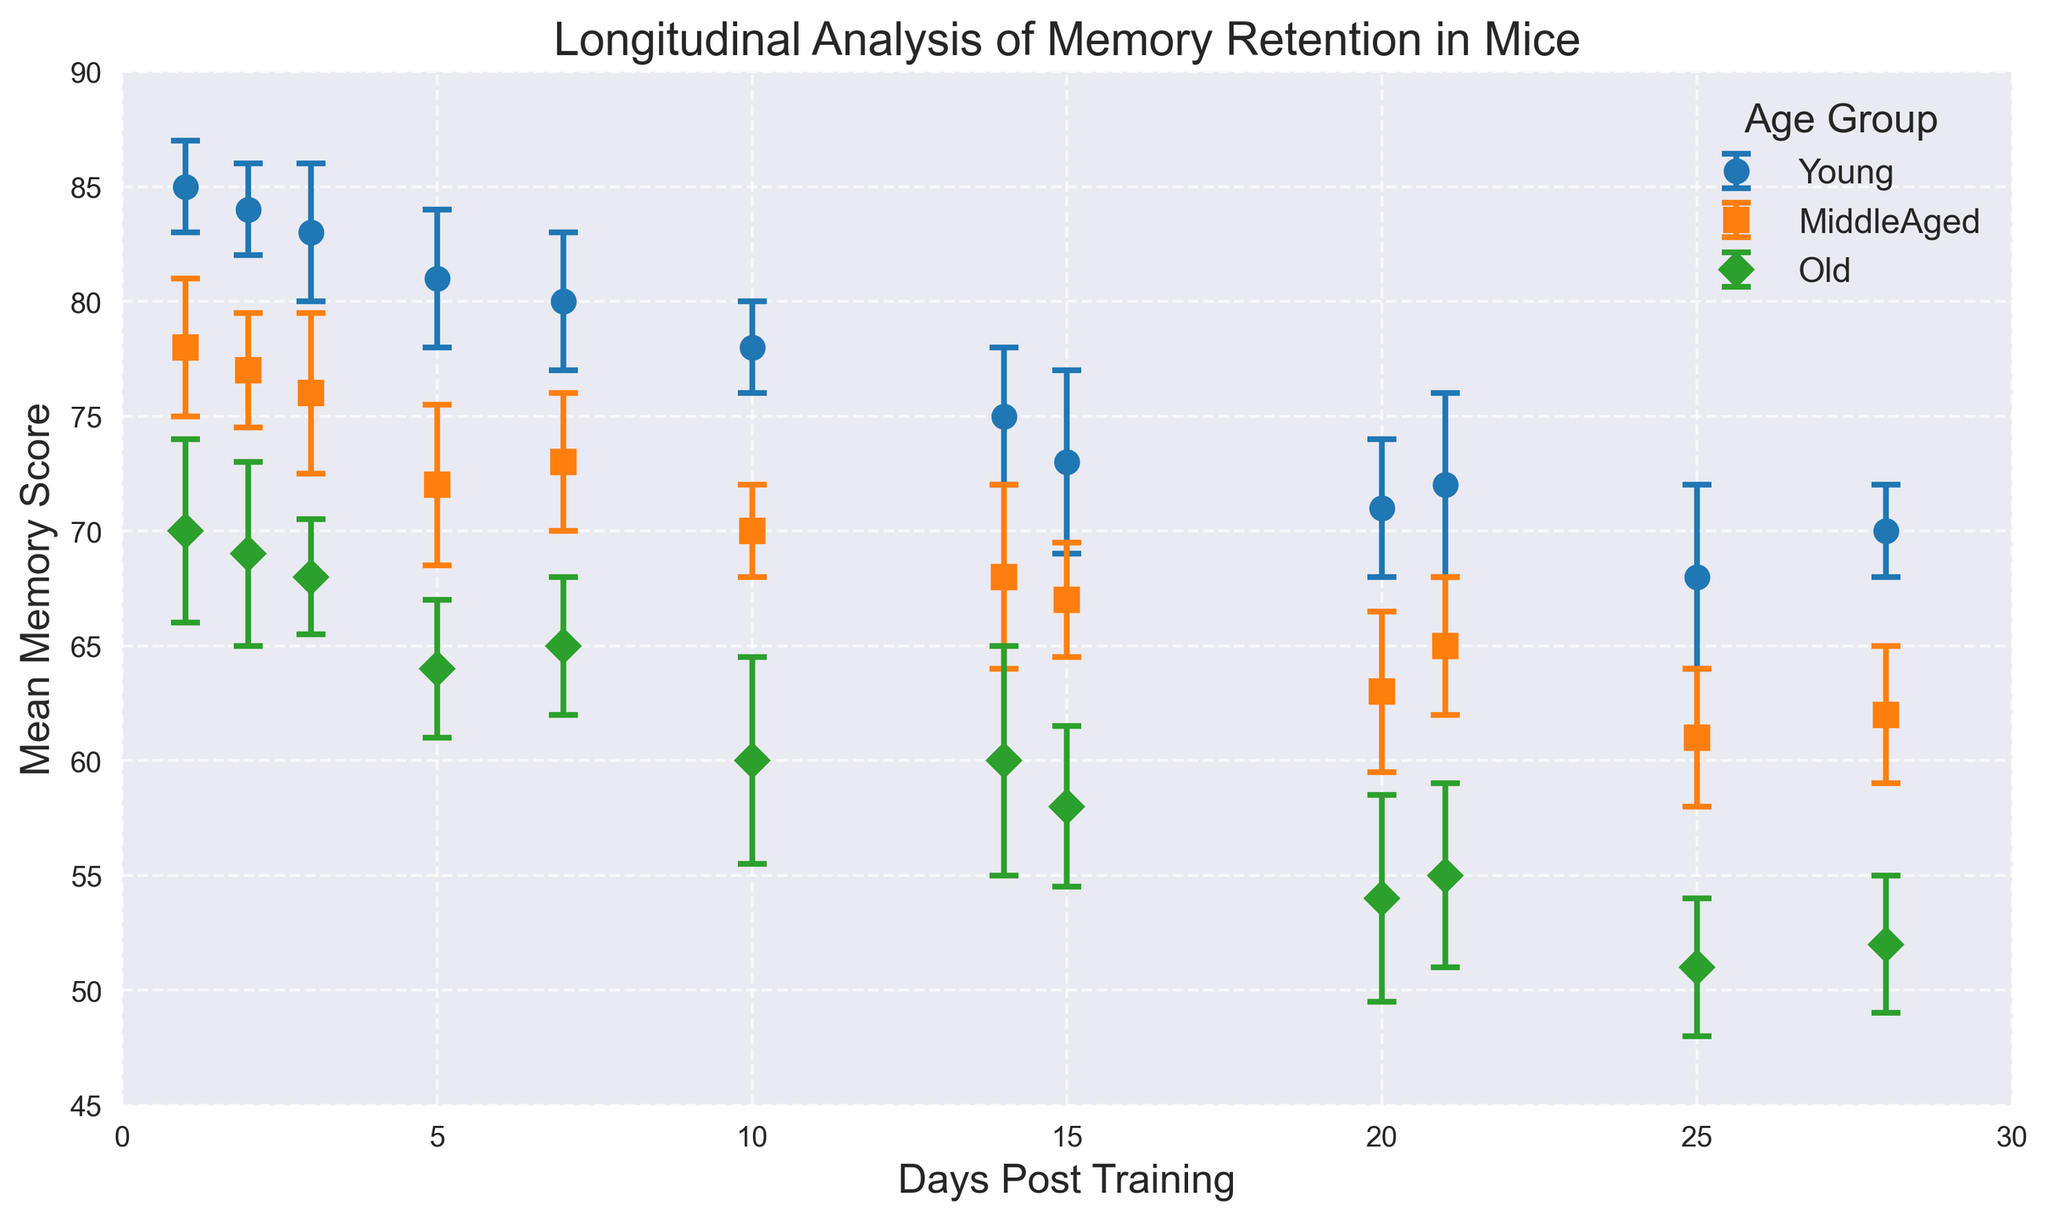What age group shows the highest mean memory score at Day 1 post-training? The highest mean memory score at Day 1 post-training can be identified by looking at the y-values of the markers for each age group at the x-position '1'. Comparing the values, Young has 85, MiddleAged has 78, and Old has 70.
Answer: Young How does the mean memory score for the MiddleAged group change from Day 1 to Day 28? To determine the change, subtract the mean memory score at Day 28 from the mean memory score at Day 1 for the MiddleAged group. The values are 78 (Day 1) and 62 (Day 28), so the change is 78 - 62.
Answer: 16 Which age group has the steepest decline in memory scores over the 28-day period? To find the steepest decline, calculate the difference between the mean memory scores at Day 1 and Day 28 for each age group. For Young: 85 - 70 = 15, MiddleAged: 78 - 62 = 16, Old: 70 - 52 = 18. The Old group has the highest difference, indicating the steepest decline.
Answer: Old How does the variability of memory scores compare between the Young and Old groups at Day 14? The variability can be assessed by looking at the length of the error bars (standard error). At Day 14, the standard error for Young is 3 and for Old is 5, indicating that the Old group has higher variability.
Answer: Old What is the mean memory retention score for the Old group at Day 10, and how does it compare to the same-day score for the MiddleAged group? First, note the mean memory scores at Day 10 for Old (60) and MiddleAged (70). By comparing these, we see that the MiddleAged group has a higher score than the Old group.
Answer: 60, MiddleAged higher What is the trend in memory retention for the Young mice between Day 1 and Day 10? The trend can be observed by tracking the markers for the Young group from Day 1 (85) to Day 10 (78). This indicates a decreasing trend in memory retention over this period.
Answer: Decreasing At which days do the Old mice have a mean memory score higher than 60? Examine the Old group’s mean memory scores at each day: Day 1 (70), Day 2 (69), Day 3 (68), and Day 5 (64). These values are higher than 60. After Day 5, the values drop below 60.
Answer: Days 1, 2, 3, 5 What is the standard error for the MiddleAged group at Day 20? Check the error bar length for the MiddleAged group at Day 20, which represents the standard error. According to the data, the standard error for MiddleAged at Day 20 is 3.5.
Answer: 3.5 